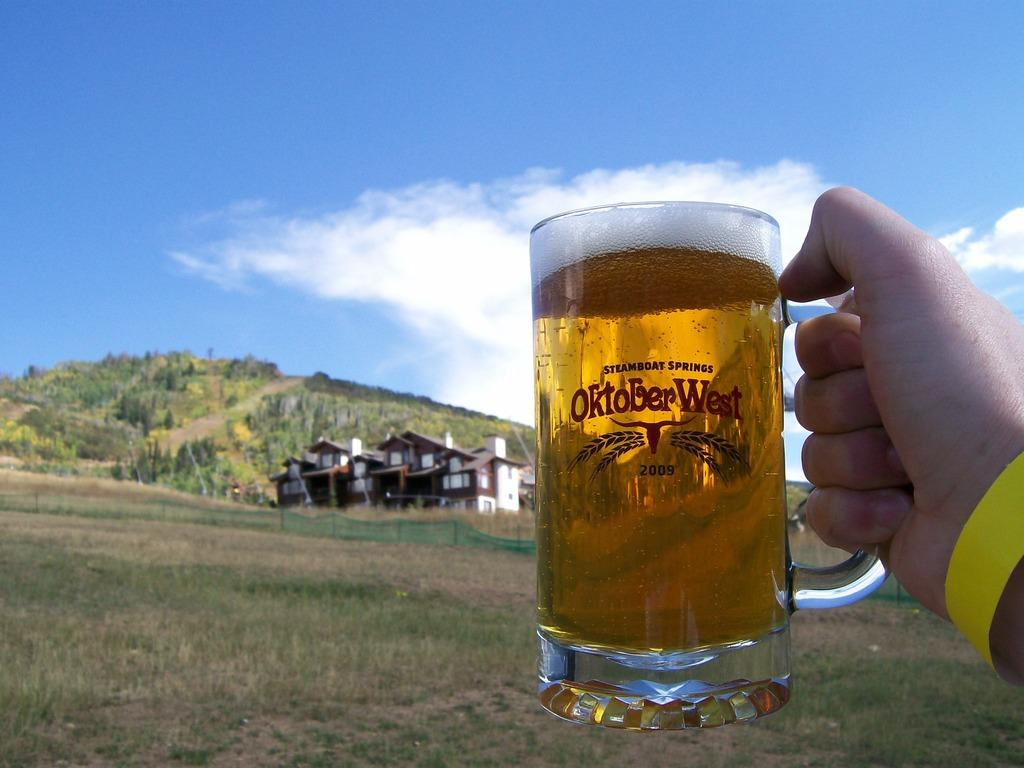Provide a one-sentence caption for the provided image. A glass of beer that says steamboat springs October West. 